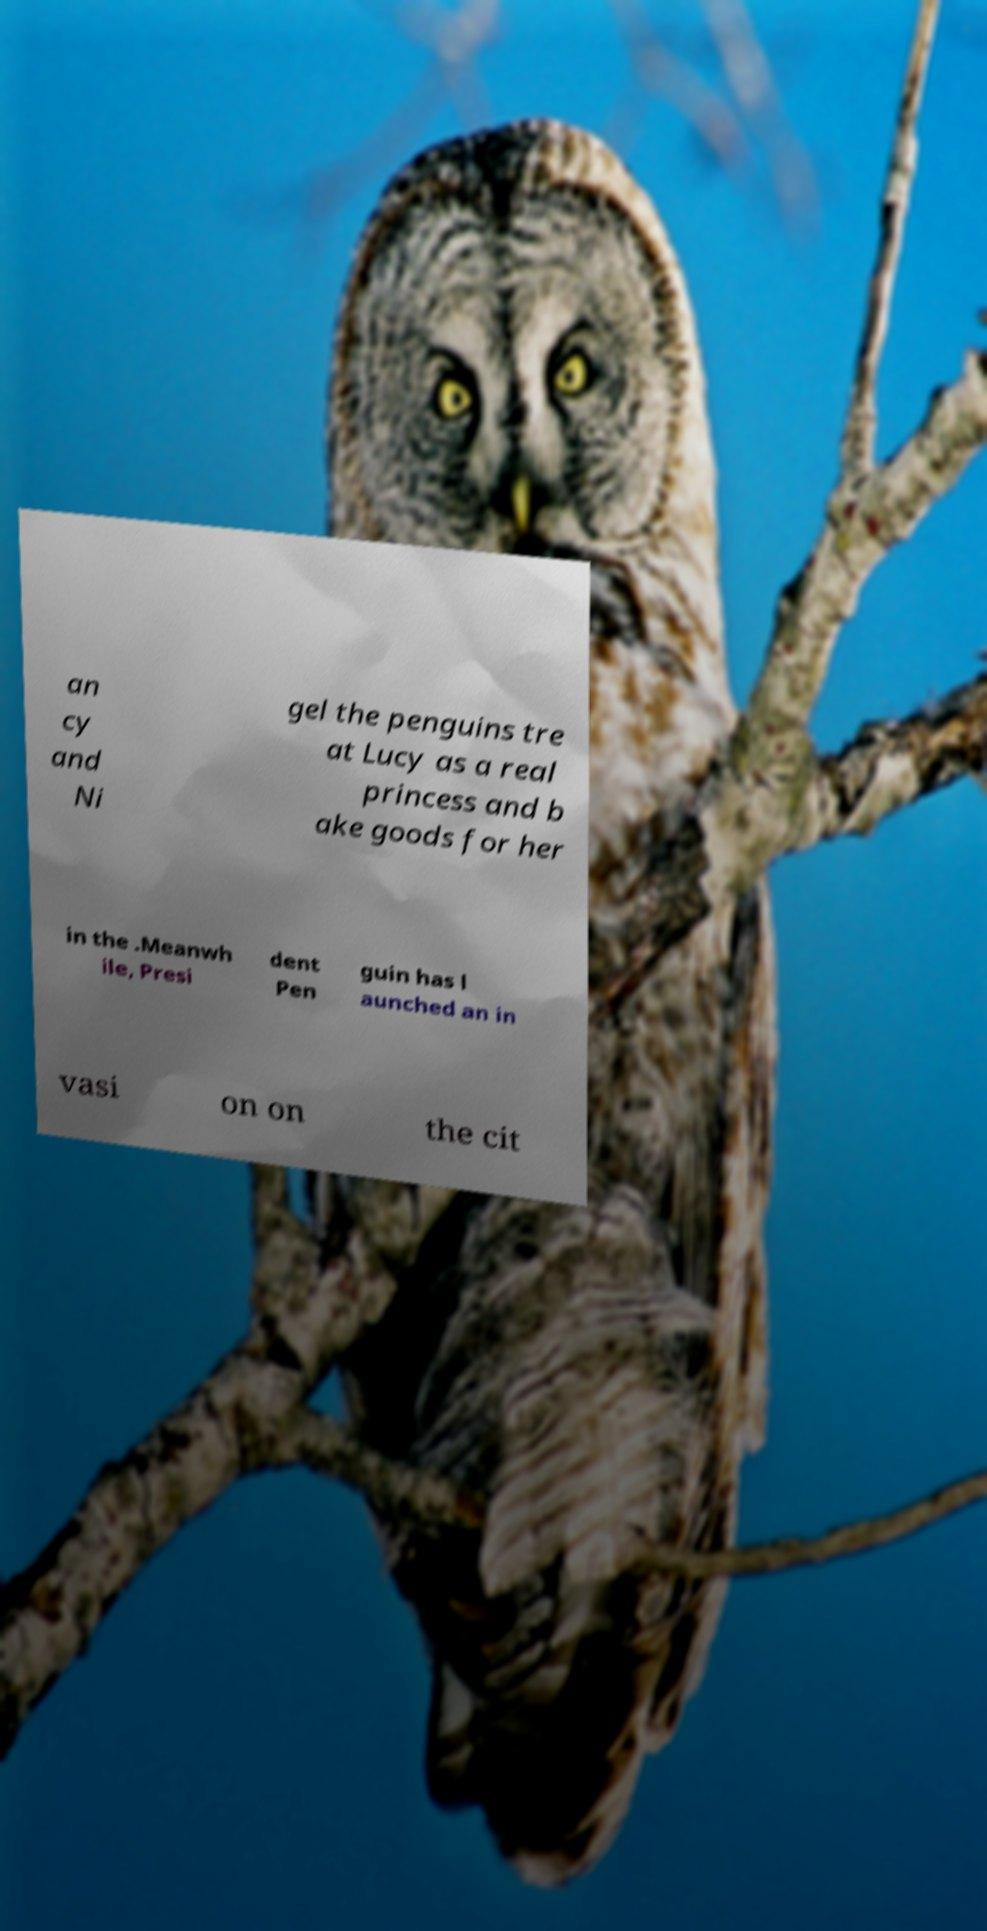Could you assist in decoding the text presented in this image and type it out clearly? an cy and Ni gel the penguins tre at Lucy as a real princess and b ake goods for her in the .Meanwh ile, Presi dent Pen guin has l aunched an in vasi on on the cit 